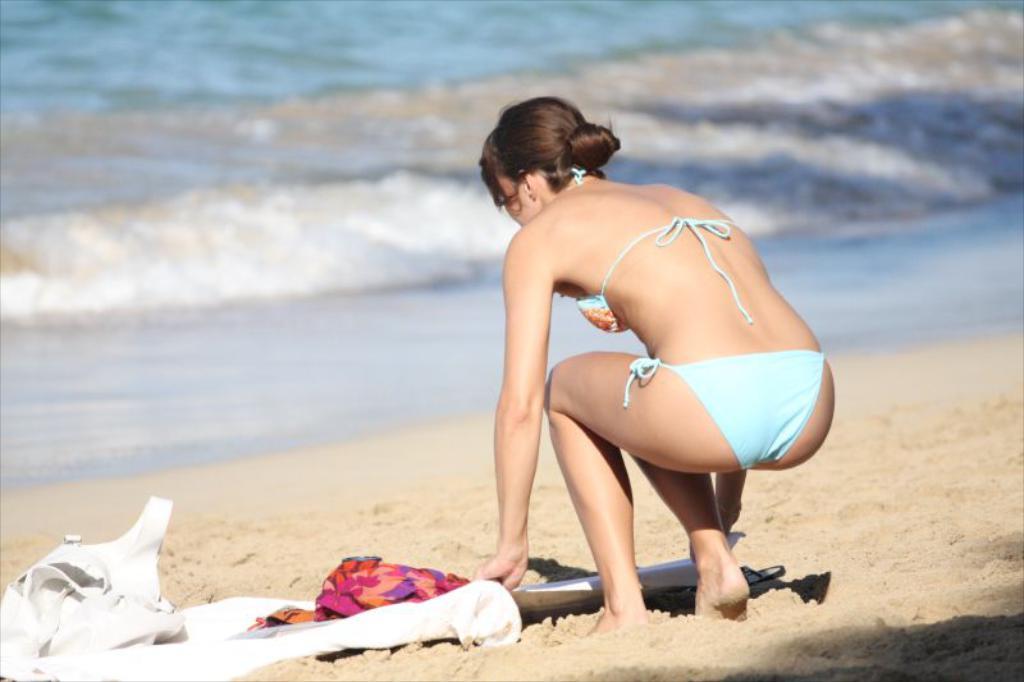Please provide a concise description of this image. In this image in the center there is one woman who is bending and she is holding clothes, at the bottom there is sand and on the sand there are some clothes. In the background there is beach. 